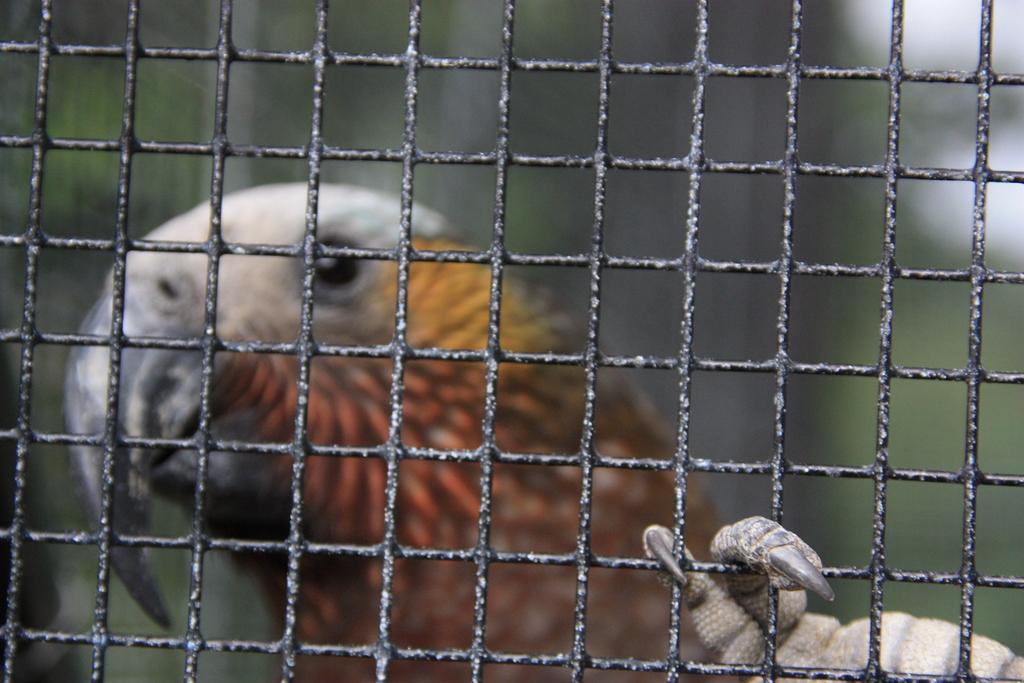What type of animal can be seen in the image? There is a bird in the image. What is located in the foreground of the image? There is a mesh in the foreground of the image. What type of space is visible in the image? There is no space visible in the image; it features a bird and a mesh. How many times does the bird need to copy itself in the image? The bird does not need to copy itself in the image; it is a single bird. 